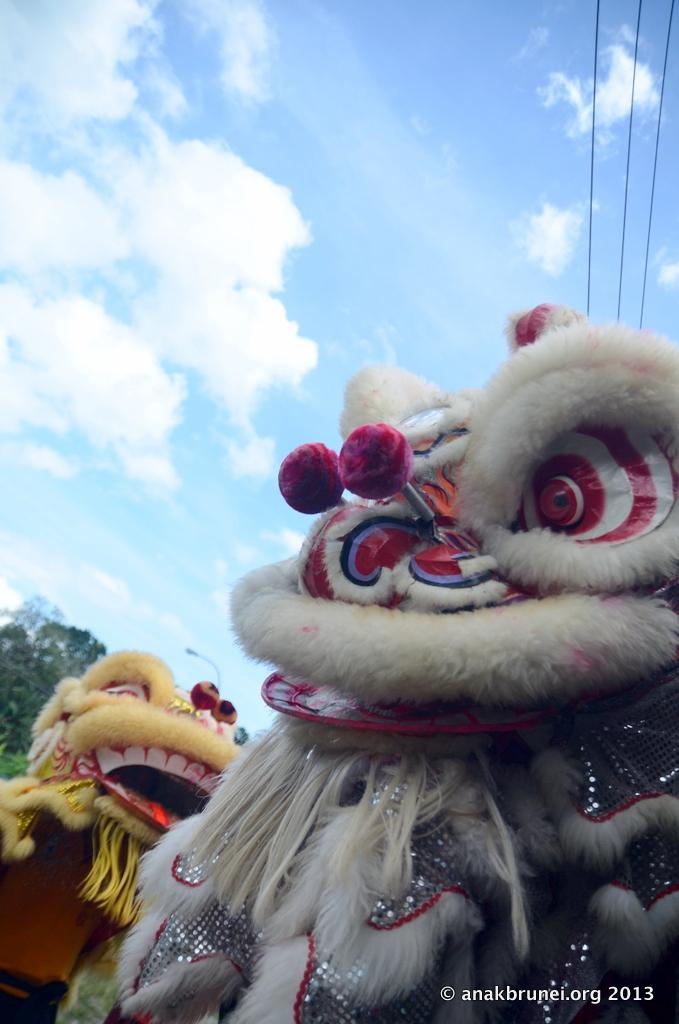What type of characters can be seen in the image? There are mascots in the image. What else can be seen in the image besides the mascots? There are wires visible in the image. What can be seen in the background of the image? Leaves and the sky are visible in the background of the image. What is the condition of the sky in the image? Clouds are present in the sky. What type of clam is being used as a property in the image? There is no clam present in the image, and no property is being used. What emotion is being expressed by the mascots in the image? The image does not convey any specific emotion, such as hate, as it only shows mascots and other elements. 